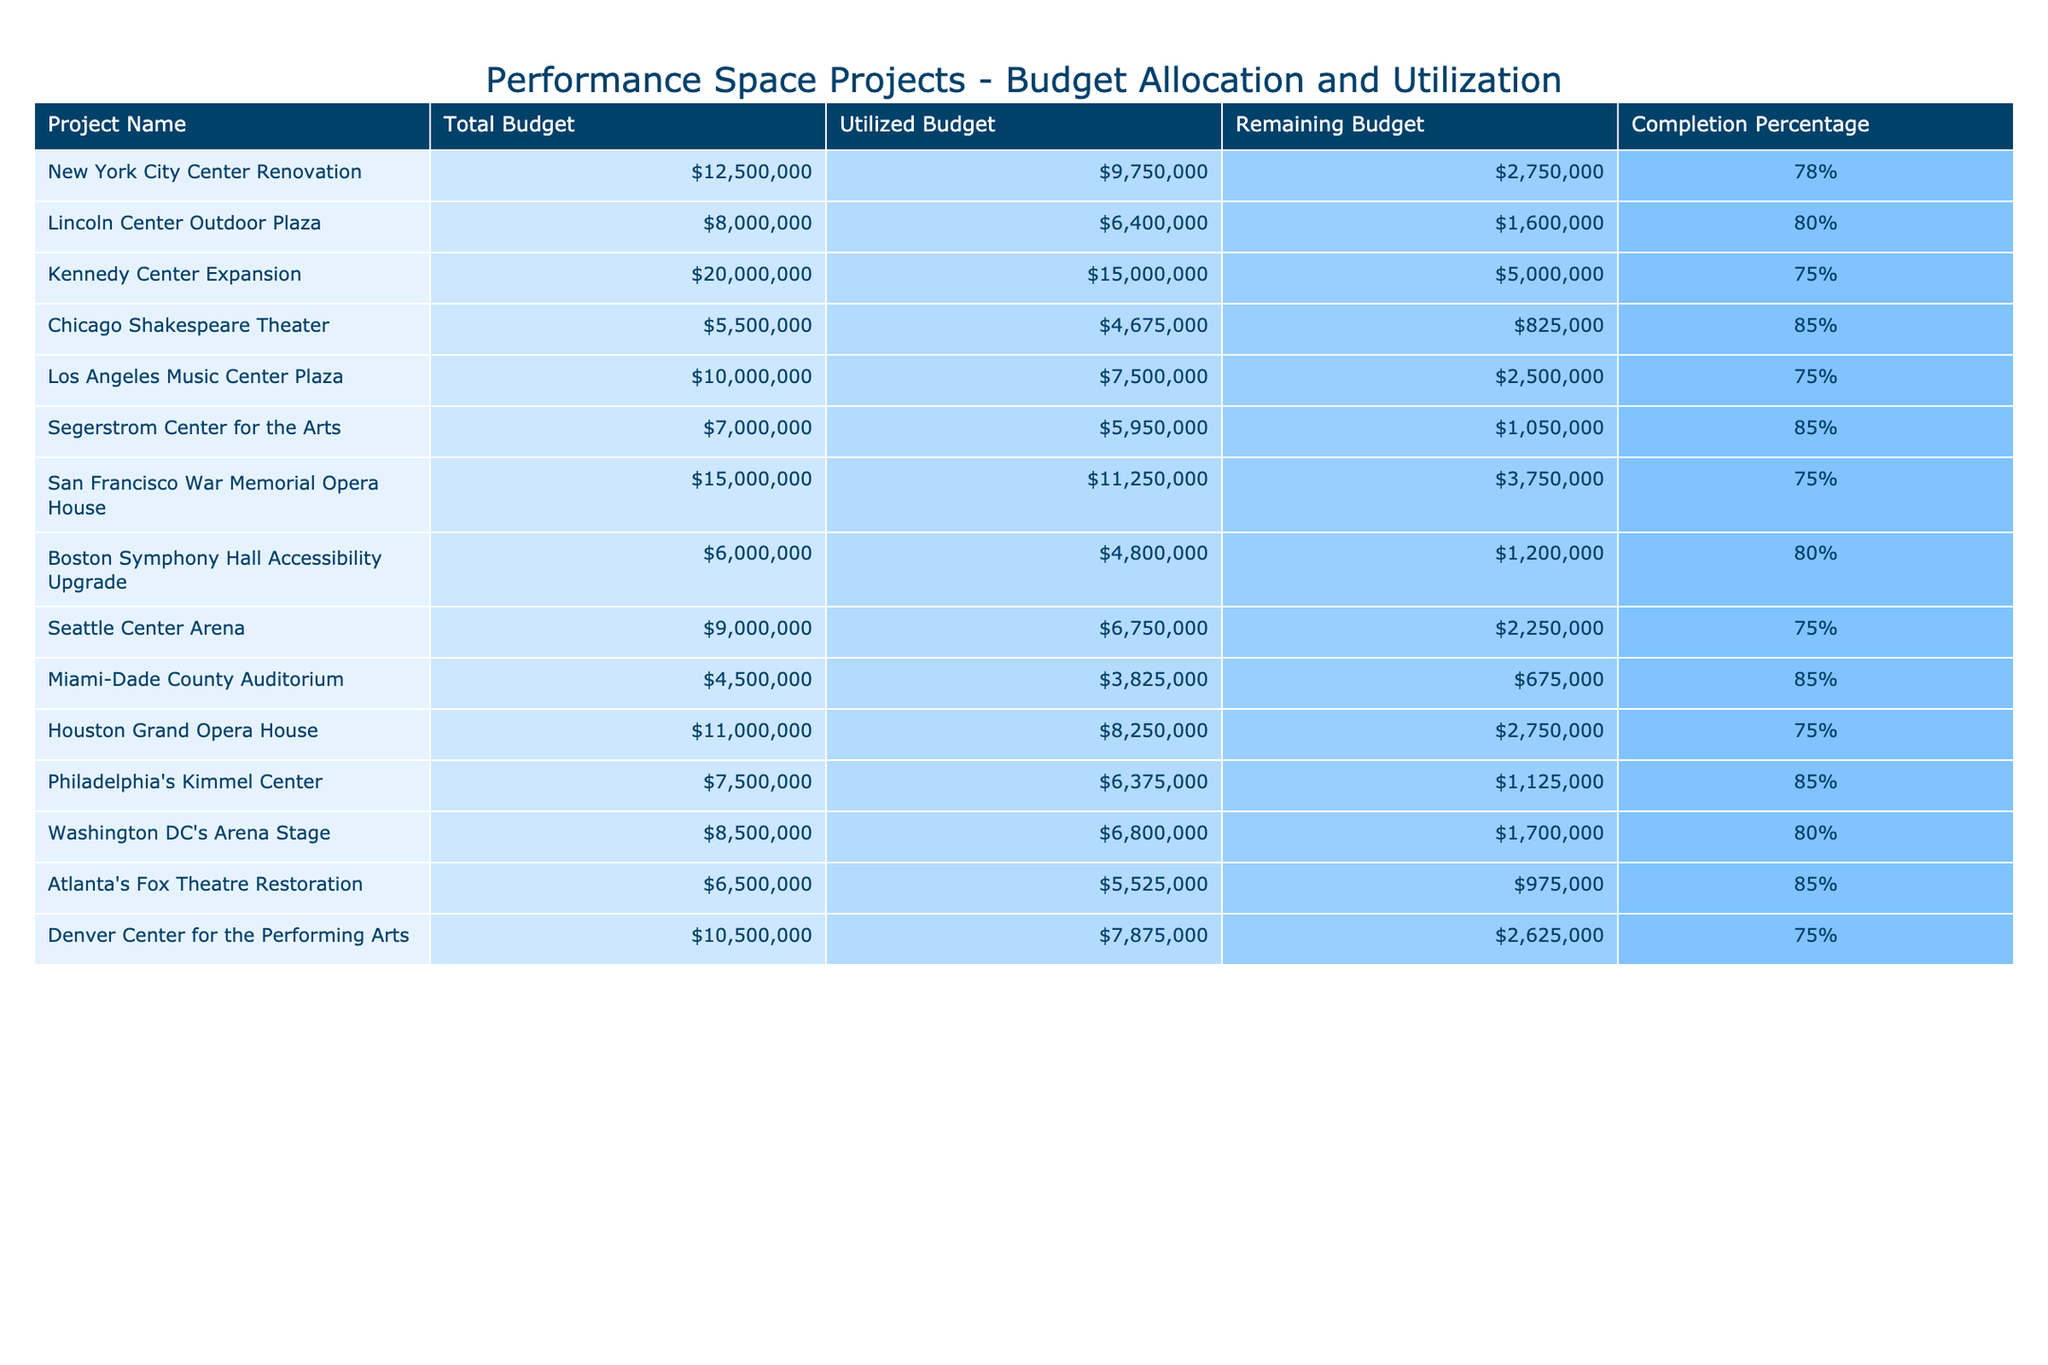What is the total budget allocated for the Chicago Shakespeare Theater project? The total budget for the Chicago Shakespeare Theater project is listed directly in the table under the 'Total Budget' column, which shows $5,500,000.
Answer: $5,500,000 How much of the budget has been utilized for the New York City Center Renovation? The utilized budget for the New York City Center Renovation is provided in the table under the 'Utilized Budget' column, which states $9,750,000.
Answer: $9,750,000 What is the remaining budget for the Kennedy Center Expansion? The remaining budget for the Kennedy Center Expansion is directly available in the 'Remaining Budget' column of the table, indicating it is $5,000,000.
Answer: $5,000,000 Which project has the highest completion percentage? By examining the 'Completion Percentage' column, we find that the Chicago Shakespeare Theater has the highest completion percentage at 85%.
Answer: Chicago Shakespeare Theater What is the difference between the total budget and the utilized budget for the Segerstrom Center for the Arts? The total budget for the Segerstrom Center for the Arts is $7,000,000, and the utilized budget is $5,950,000. The difference is calculated by subtracting the utilized budget from the total budget: $7,000,000 - $5,950,000 = $1,050,000.
Answer: $1,050,000 How much budget has been utilized across all projects? To find the total utilized budget, sum each project's utilized budget values: $9,750,000 + $6,400,000 + $15,000,000 + $4,675,000 + $7,500,000 + $5,950,000 + $11,250,000 + $4,800,000 + $6,750,000 + $3,825,000 + $8,250,000 + $6,375,000 + $6,800,000 + $5,525,000 + $7,875,000 = $104,475,000.
Answer: $104,475,000 Is the total budget for the Boston Symphony Hall Accessibility Upgrade greater than the remaining budget for the Los Angeles Music Center Plaza? The total budget for the Boston Symphony Hall Accessibility Upgrade is $6,000,000, and the remaining budget for the Los Angeles Music Center Plaza is $2,500,000. Since $6,000,000 is greater than $2,500,000, the statement is true.
Answer: Yes What is the average completion percentage of all projects? To calculate the average completion percentage, sum the completion percentages (sum = 78 + 80 + 75 + 85 + 75 + 85 + 75 + 80 + 75 + 85 + 85 + 80 + 85 + 85 + 75 = 1,275) and then divide by the number of projects (15): 1,275 / 15 = 85%.
Answer: 85% Which project has the lowest remaining budget? To identify the project with the lowest remaining budget, we check the 'Remaining Budget' column. The Miami-Dade County Auditorium has a remaining budget of $675,000, which is the lowest.
Answer: Miami-Dade County Auditorium What is the total amount of budget utilized for projects that have a completion percentage of 80% or higher? The projects with a completion percentage of 80% or higher are Lincoln Center Outdoor Plaza, Chicago Shakespeare Theater, Segerstrom Center for the Arts, Boston Symphony Hall Accessibility Upgrade, Philadelphia's Kimmel Center, Washington DC's Arena Stage, and Atlanta's Fox Theatre Restoration. Their utilized budgets are $6,400,000 + $4,675,000 + $5,950,000 + $4,800,000 + $6,375,000 + $6,800,000 + $5,525,000 = $40,925,000.
Answer: $40,925,000 